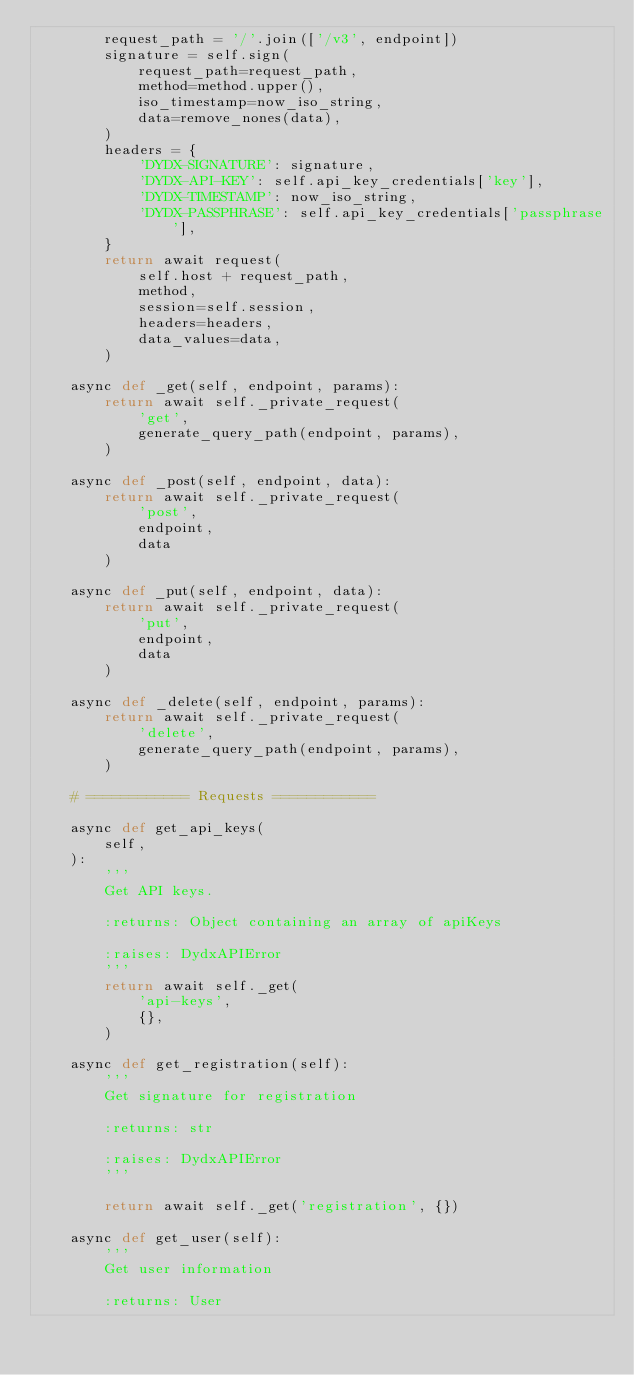<code> <loc_0><loc_0><loc_500><loc_500><_Python_>        request_path = '/'.join(['/v3', endpoint])
        signature = self.sign(
            request_path=request_path,
            method=method.upper(),
            iso_timestamp=now_iso_string,
            data=remove_nones(data),
        )
        headers = {
            'DYDX-SIGNATURE': signature,
            'DYDX-API-KEY': self.api_key_credentials['key'],
            'DYDX-TIMESTAMP': now_iso_string,
            'DYDX-PASSPHRASE': self.api_key_credentials['passphrase'],
        }
        return await request(
            self.host + request_path,
            method,
            session=self.session,
            headers=headers,
            data_values=data,
        )

    async def _get(self, endpoint, params):
        return await self._private_request(
            'get',
            generate_query_path(endpoint, params),
        )

    async def _post(self, endpoint, data):
        return await self._private_request(
            'post',
            endpoint,
            data
        )

    async def _put(self, endpoint, data):
        return await self._private_request(
            'put',
            endpoint,
            data
        )

    async def _delete(self, endpoint, params):
        return await self._private_request(
            'delete',
            generate_query_path(endpoint, params),
        )

    # ============ Requests ============

    async def get_api_keys(
        self,
    ):
        '''
        Get API keys.

        :returns: Object containing an array of apiKeys

        :raises: DydxAPIError
        '''
        return await self._get(
            'api-keys',
            {},
        )

    async def get_registration(self):
        '''
        Get signature for registration

        :returns: str

        :raises: DydxAPIError
        '''

        return await self._get('registration', {})

    async def get_user(self):
        '''
        Get user information

        :returns: User
</code> 